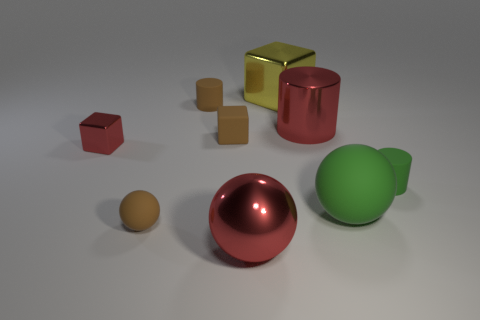There is a rubber thing that is both in front of the tiny red block and left of the matte block; how big is it?
Your response must be concise. Small. Is there anything else that is the same color as the large cylinder?
Provide a short and direct response. Yes. There is a red object that is right of the large red metal thing that is in front of the small brown rubber block; what is its size?
Offer a very short reply. Large. What color is the large thing that is both in front of the small metal block and behind the shiny sphere?
Your answer should be very brief. Green. What number of other objects are the same size as the brown block?
Keep it short and to the point. 4. There is a matte block; is it the same size as the metal cube in front of the big yellow metallic object?
Keep it short and to the point. Yes. The cylinder that is the same size as the green sphere is what color?
Your response must be concise. Red. How big is the brown rubber block?
Provide a succinct answer. Small. Are the large thing that is in front of the green sphere and the large yellow cube made of the same material?
Offer a very short reply. Yes. Do the small green thing and the tiny red thing have the same shape?
Provide a succinct answer. No. 